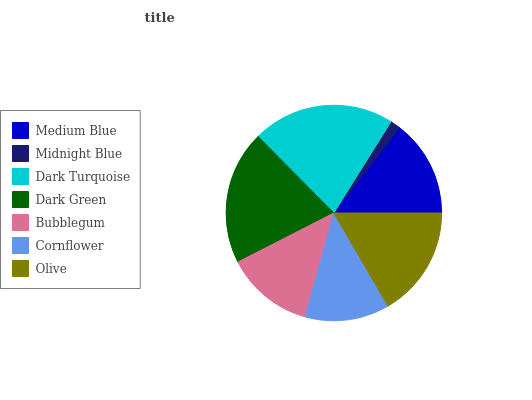Is Midnight Blue the minimum?
Answer yes or no. Yes. Is Dark Turquoise the maximum?
Answer yes or no. Yes. Is Dark Turquoise the minimum?
Answer yes or no. No. Is Midnight Blue the maximum?
Answer yes or no. No. Is Dark Turquoise greater than Midnight Blue?
Answer yes or no. Yes. Is Midnight Blue less than Dark Turquoise?
Answer yes or no. Yes. Is Midnight Blue greater than Dark Turquoise?
Answer yes or no. No. Is Dark Turquoise less than Midnight Blue?
Answer yes or no. No. Is Medium Blue the high median?
Answer yes or no. Yes. Is Medium Blue the low median?
Answer yes or no. Yes. Is Olive the high median?
Answer yes or no. No. Is Bubblegum the low median?
Answer yes or no. No. 